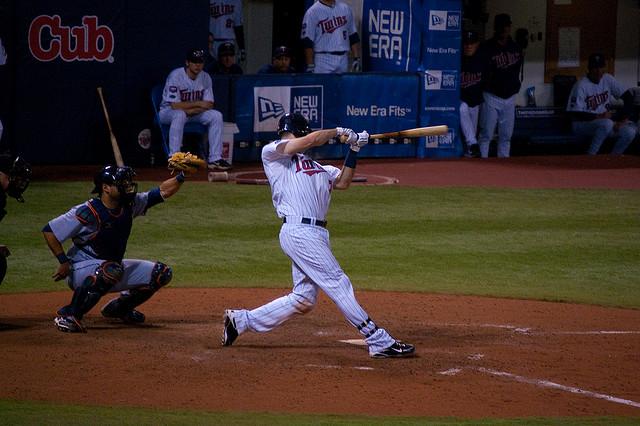What team is up to bat?
Write a very short answer. Twins. How many stripes are on each man's pants?
Write a very short answer. 20. What kinds of shoes would he be wearing?
Short answer required. Cleats. What does it say on the wall?
Be succinct. Cub. What is this man doing?
Concise answer only. Playing baseball. 